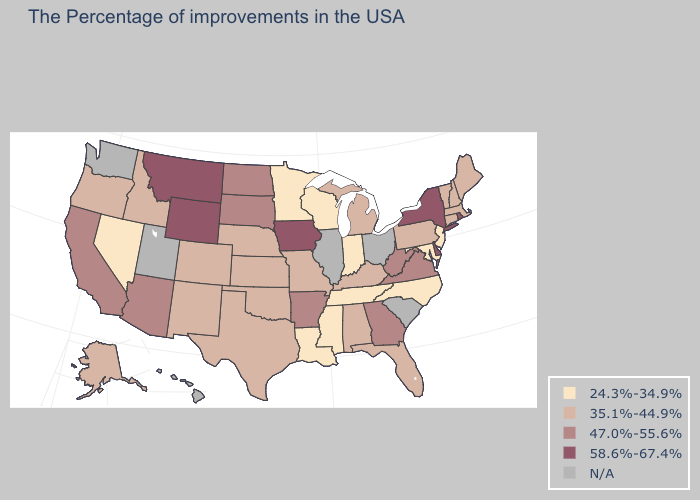Which states have the highest value in the USA?
Short answer required. Rhode Island, New York, Delaware, Iowa, Wyoming, Montana. What is the value of Iowa?
Write a very short answer. 58.6%-67.4%. Does the first symbol in the legend represent the smallest category?
Give a very brief answer. Yes. What is the value of Nebraska?
Answer briefly. 35.1%-44.9%. What is the value of Mississippi?
Be succinct. 24.3%-34.9%. Among the states that border Colorado , which have the highest value?
Short answer required. Wyoming. What is the lowest value in the South?
Answer briefly. 24.3%-34.9%. What is the highest value in states that border Mississippi?
Give a very brief answer. 47.0%-55.6%. Does Georgia have the highest value in the USA?
Quick response, please. No. Name the states that have a value in the range 58.6%-67.4%?
Short answer required. Rhode Island, New York, Delaware, Iowa, Wyoming, Montana. Among the states that border Arizona , does California have the highest value?
Give a very brief answer. Yes. What is the value of Arkansas?
Keep it brief. 47.0%-55.6%. What is the lowest value in the South?
Quick response, please. 24.3%-34.9%. 